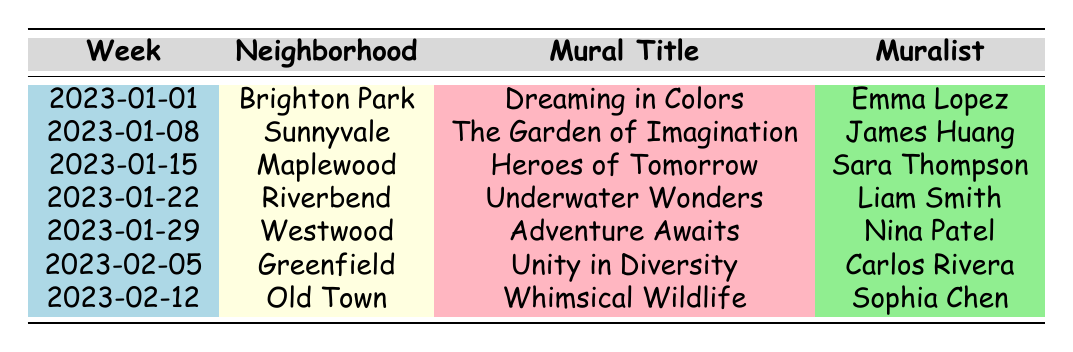What is the title of the mural completed in Riverbend? The table lists the projects completed in each neighborhood, where Riverbend is noted with the mural title "Underwater Wonders".
Answer: Underwater Wonders Who is the muralist for "Unity in Diversity"? The table indicates that the mural titled "Unity in Diversity" was created by Carlos Rivera in Greenfield.
Answer: Carlos Rivera What is the theme of the mural created by Emma Lopez? According to the table, Emma Lopez's mural "Dreaming in Colors" has the theme of "Childhood Dreams".
Answer: Childhood Dreams How many hours did it take to complete the mural "The Garden of Imagination"? The table shows that the completion time for "The Garden of Imagination" is listed as 15 hours.
Answer: 15 hours Which mural took the most hours to complete? By comparing the completion times listed, "Underwater Wonders" took the most time at 18 hours, while all others are less.
Answer: Underwater Wonders Are there any murals with the theme of "Animals and Nature"? Yes, the table shows that "Whimsical Wildlife" has the theme of "Animals and Nature", created by Sophia Chen.
Answer: Yes What is the average completion time of the murals listed? Adding the completion times: 12 + 15 + 10 + 18 + 14 + 11 + 13 = 93 hours. There are 7 murals, so the average is 93/7 ≈ 13.29 hours.
Answer: Approximately 13.29 hours How many murals were completed in January 2023? The table shows 5 murals completed, specifically from January 1st to January 29th, in different neighborhoods.
Answer: 5 murals Which neighborhood had the mural with the longest title? Looking at the titles in the table, "The Garden of Imagination" is the longest title and it's in Sunnyvale.
Answer: Sunnyvale What is the color used in the mural "Adventure Awaits"? The table lists the colors used in "Adventure Awaits" as Tangerine, Lime, Fuchsia, and Indigo.
Answer: Tangerine, Lime, Fuchsia, Indigo Did Sara Thompson work on a mural with a completion time shorter than 12 hours? The table indicates that Sara Thompson completed "Heroes of Tomorrow" in 10 hours, which is shorter than 12 hours.
Answer: Yes In which week was the mural "Dreaming in Colors" completed? The table specifies that "Dreaming in Colors" was completed in the week of January 1, 2023.
Answer: January 1, 2023 Which muralist created the mural with the fewest colors used? The table shows that "Heroes of Tomorrow" by Sara Thompson features colors Black, White, Gold, and Silver, totaling four colors, which is the fewest used.
Answer: Sara Thompson 